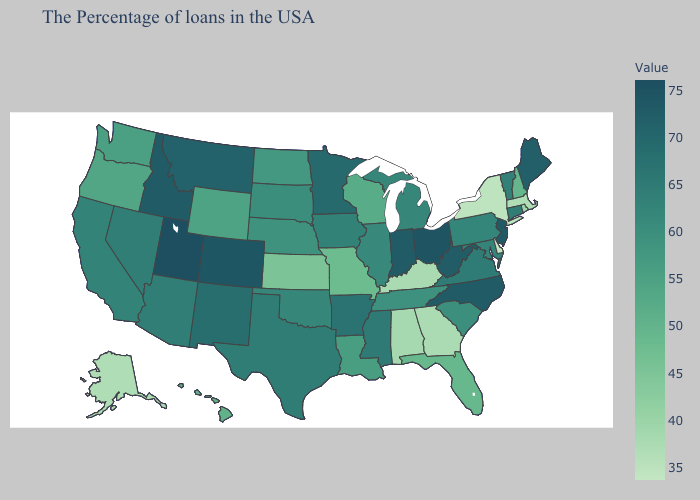Does Utah have a higher value than Pennsylvania?
Write a very short answer. Yes. Does Virginia have the lowest value in the USA?
Give a very brief answer. No. Among the states that border Nebraska , does Wyoming have the highest value?
Be succinct. No. Does North Dakota have a lower value than Missouri?
Concise answer only. No. Is the legend a continuous bar?
Short answer required. Yes. Does Delaware have the lowest value in the USA?
Keep it brief. Yes. 